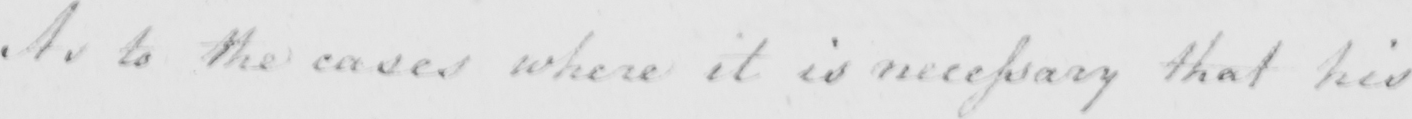Please provide the text content of this handwritten line. As to the cases where it is necessary that his 